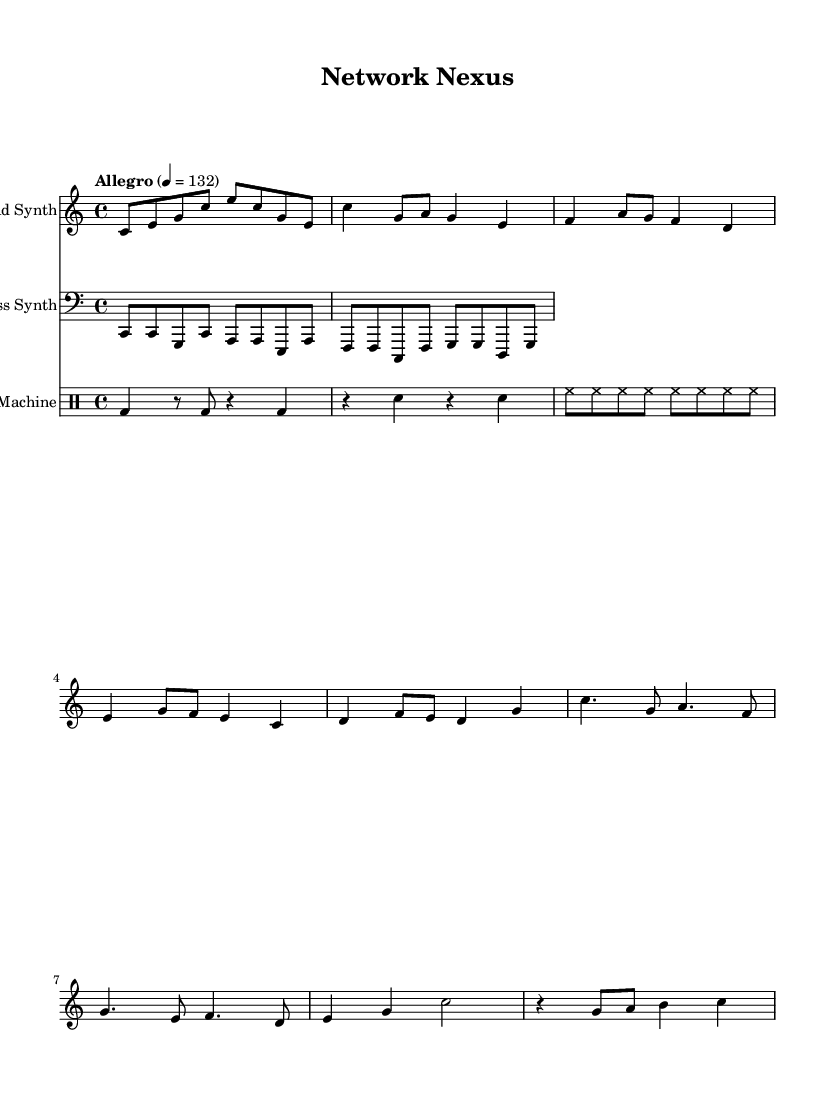What is the key signature of this music? The key signature is specified as C major, which means there are no sharps or flats in the key. This can be identified by looking for the key signature symbol at the beginning of the staff.
Answer: C major What is the time signature of the music? The time signature is indicated at the beginning of the piece as 4/4. This means there are four beats in each measure and the quarter note gets one beat. This is typically marked near the leftmost side of the sheet music.
Answer: 4/4 What is the tempo marking for this piece? The tempo marking is noted as "Allegro," with a metronome marking of 132. This indicates a fast and lively speed for the performance, generally characteristic of upbeat electronic music.
Answer: Allegro 4 = 132 How many measures are in the lead synth section? By counting the measures from the start of the lead synth part to the end, you can determine the total number of measures. The lead synth section contains 8 measures in total.
Answer: 8 What instrument is used for the drum pattern? The drum pattern is performed by the "Drum Machine," which is explicitly mentioned in the instrument name at the beginning of that staff. The notation uses drum-specific symbols to communicate the rhythm.
Answer: Drum Machine How does the bass synth interact with the lead synth in terms of rhythm? The bass synth plays a straightforward rhythmic pattern that complements the lead synth by providing a steady pulse and supporting the harmonic structure, characterized by synced but lower rhythmic emphasis relative to the lead.
Answer: Complementary What is the primary mood conveyed by this piece? The piece conveys an upbeat and energetic mood, suitable for enhancing focus during activities like network troubleshooting, as indicated by the lively tempo and rhythmic patterns employed throughout the composition.
Answer: Upbeat 